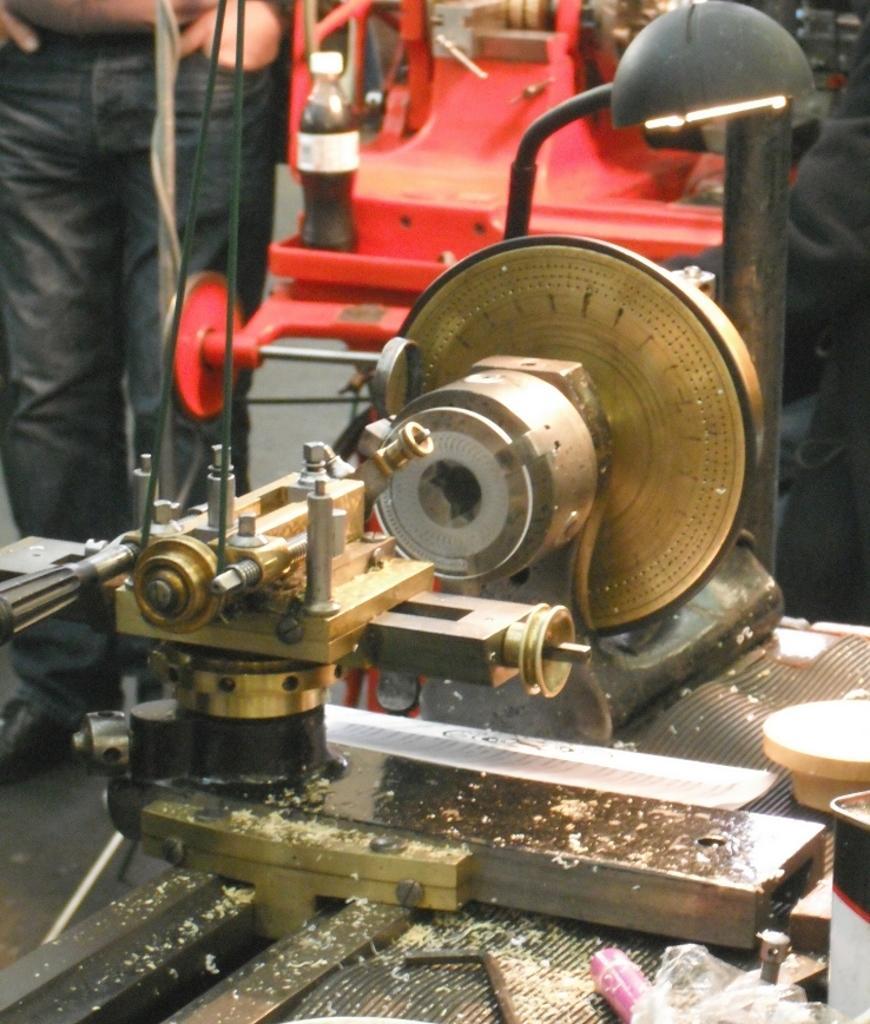How would you summarize this image in a sentence or two? In this image there is a machinery as we can see in bottom of this image and there is one person standing on the left side of this image. There is one bottle is kept on one object on the top of this image. 